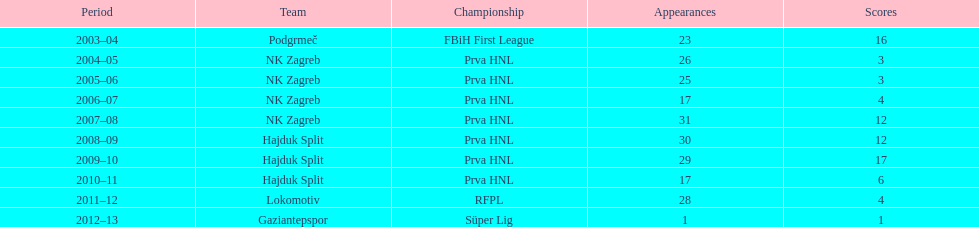Could you help me parse every detail presented in this table? {'header': ['Period', 'Team', 'Championship', 'Appearances', 'Scores'], 'rows': [['2003–04', 'Podgrmeč', 'FBiH First League', '23', '16'], ['2004–05', 'NK Zagreb', 'Prva HNL', '26', '3'], ['2005–06', 'NK Zagreb', 'Prva HNL', '25', '3'], ['2006–07', 'NK Zagreb', 'Prva HNL', '17', '4'], ['2007–08', 'NK Zagreb', 'Prva HNL', '31', '12'], ['2008–09', 'Hajduk Split', 'Prva HNL', '30', '12'], ['2009–10', 'Hajduk Split', 'Prva HNL', '29', '17'], ['2010–11', 'Hajduk Split', 'Prva HNL', '17', '6'], ['2011–12', 'Lokomotiv', 'RFPL', '28', '4'], ['2012–13', 'Gaziantepspor', 'Süper Lig', '1', '1']]} Did ibricic score more or less goals in his 3 seasons with hajduk split when compared to his 4 seasons with nk zagreb? More. 